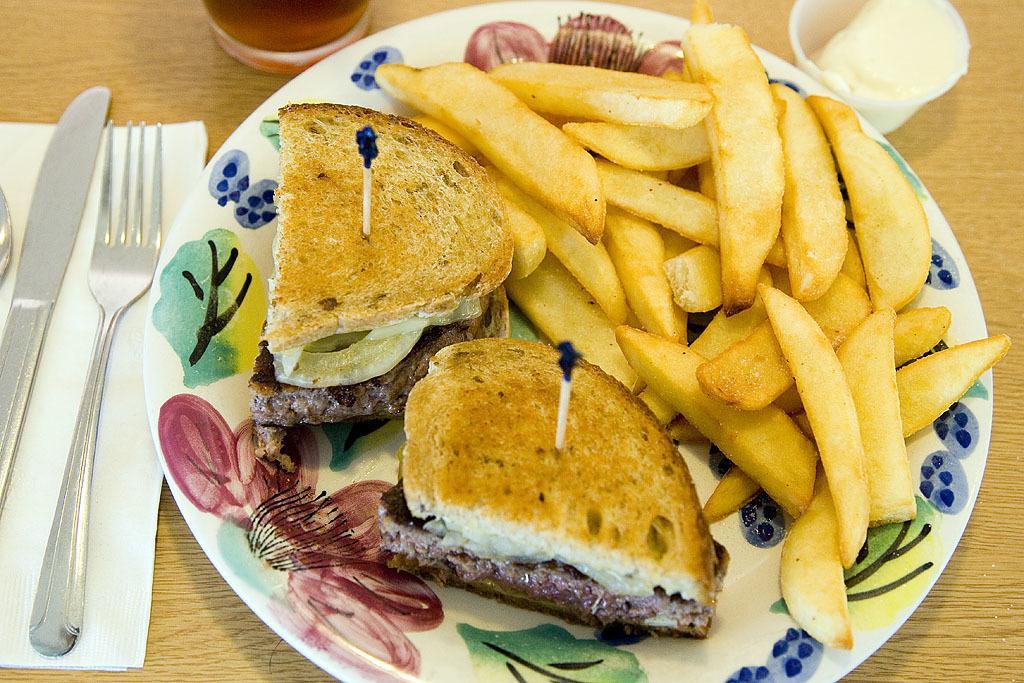Please provide a concise description of this image. In this picture I can see there is a plate of food served and there is a tissue, fork, spoons and knife. There are glasses placed on the wooden table. 